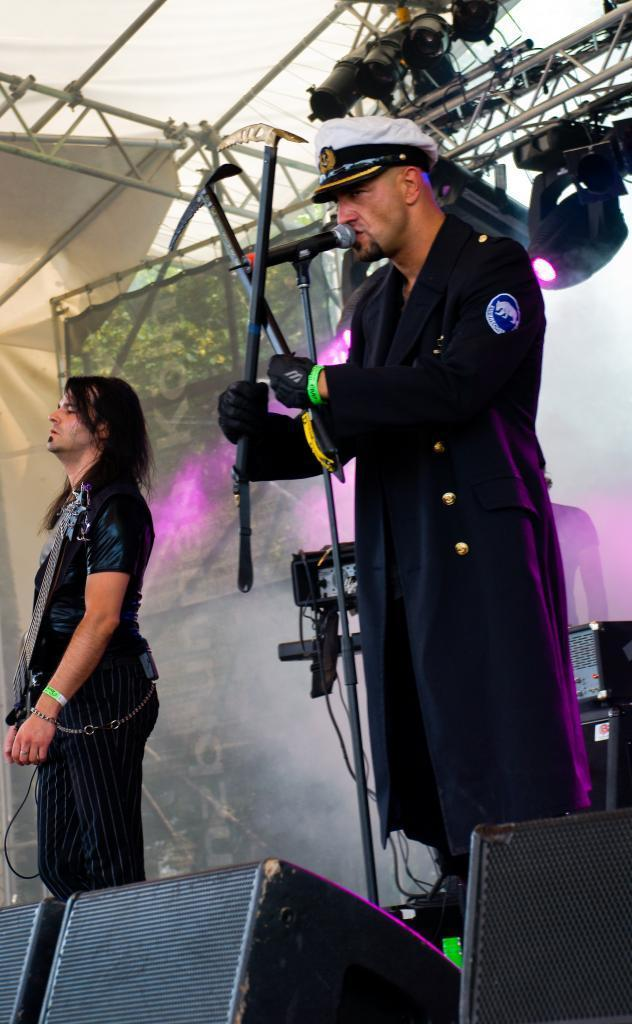How many people are in the image? There are two people in the image. What else can be seen in the image besides the two people? Musical equipment is visible in the image. What type of lighting is present in the image? Purple lights are visible in the image, focusing on the two people. What type of protest is being held by the two people in the image? There is no protest visible in the image; it features two people and musical equipment with purple lighting. Can you hear the sound of the musical equipment in the image? The image is static, so we cannot hear any sound from the musical equipment. 